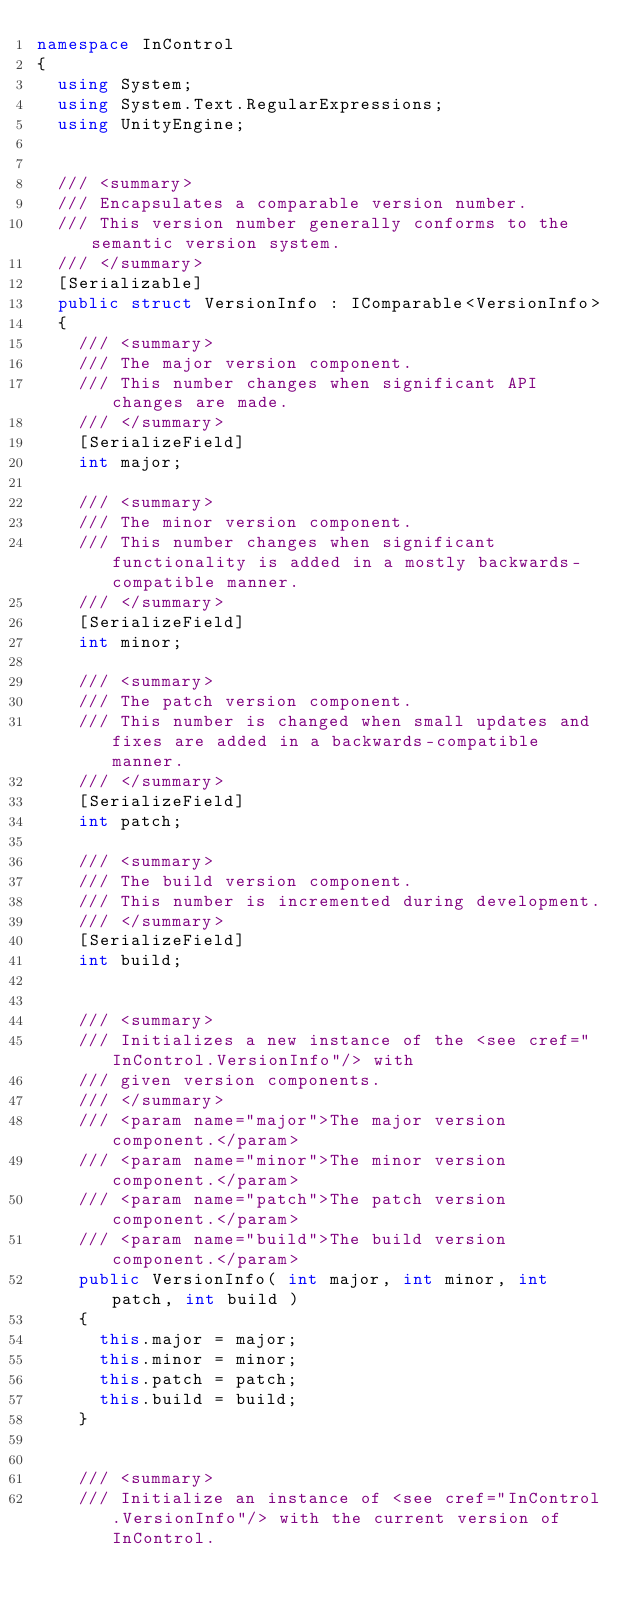<code> <loc_0><loc_0><loc_500><loc_500><_C#_>namespace InControl
{
	using System;
	using System.Text.RegularExpressions;
	using UnityEngine;


	/// <summary>
	/// Encapsulates a comparable version number.
	/// This version number generally conforms to the semantic version system.
	/// </summary>
	[Serializable]
	public struct VersionInfo : IComparable<VersionInfo>
	{
		/// <summary>
		/// The major version component.
		/// This number changes when significant API changes are made.
		/// </summary>
		[SerializeField]
		int major;

		/// <summary>
		/// The minor version component.
		/// This number changes when significant functionality is added in a mostly backwards-compatible manner.
		/// </summary>
		[SerializeField]
		int minor;

		/// <summary>
		/// The patch version component.
		/// This number is changed when small updates and fixes are added in a backwards-compatible manner.
		/// </summary>
		[SerializeField]
		int patch;

		/// <summary>
		/// The build version component.
		/// This number is incremented during development.
		/// </summary>
		[SerializeField]
		int build;


		/// <summary>
		/// Initializes a new instance of the <see cref="InControl.VersionInfo"/> with
		/// given version components.
		/// </summary>
		/// <param name="major">The major version component.</param>
		/// <param name="minor">The minor version component.</param>
		/// <param name="patch">The patch version component.</param>
		/// <param name="build">The build version component.</param>
		public VersionInfo( int major, int minor, int patch, int build )
		{
			this.major = major;
			this.minor = minor;
			this.patch = patch;
			this.build = build;
		}


		/// <summary>
		/// Initialize an instance of <see cref="InControl.VersionInfo"/> with the current version of InControl.</code> 